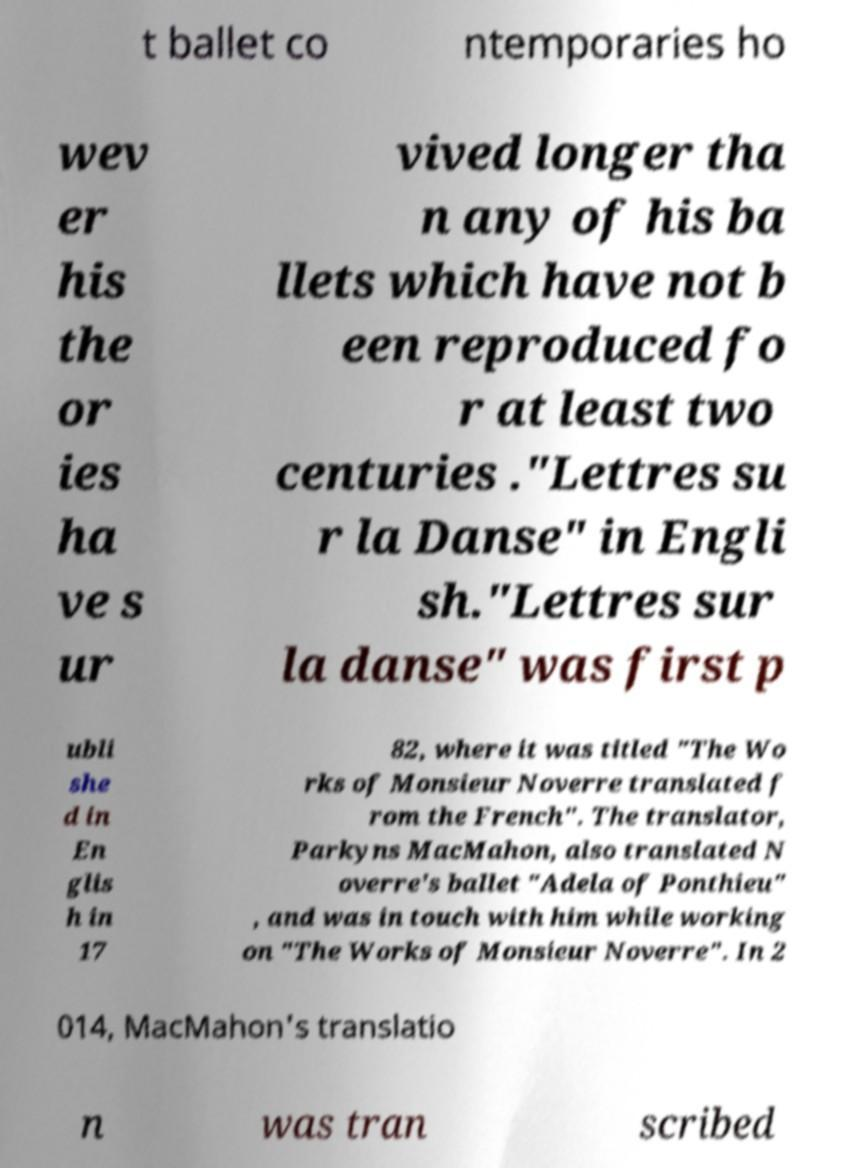Can you read and provide the text displayed in the image?This photo seems to have some interesting text. Can you extract and type it out for me? t ballet co ntemporaries ho wev er his the or ies ha ve s ur vived longer tha n any of his ba llets which have not b een reproduced fo r at least two centuries ."Lettres su r la Danse" in Engli sh."Lettres sur la danse" was first p ubli she d in En glis h in 17 82, where it was titled "The Wo rks of Monsieur Noverre translated f rom the French". The translator, Parkyns MacMahon, also translated N overre's ballet "Adela of Ponthieu" , and was in touch with him while working on "The Works of Monsieur Noverre". In 2 014, MacMahon's translatio n was tran scribed 